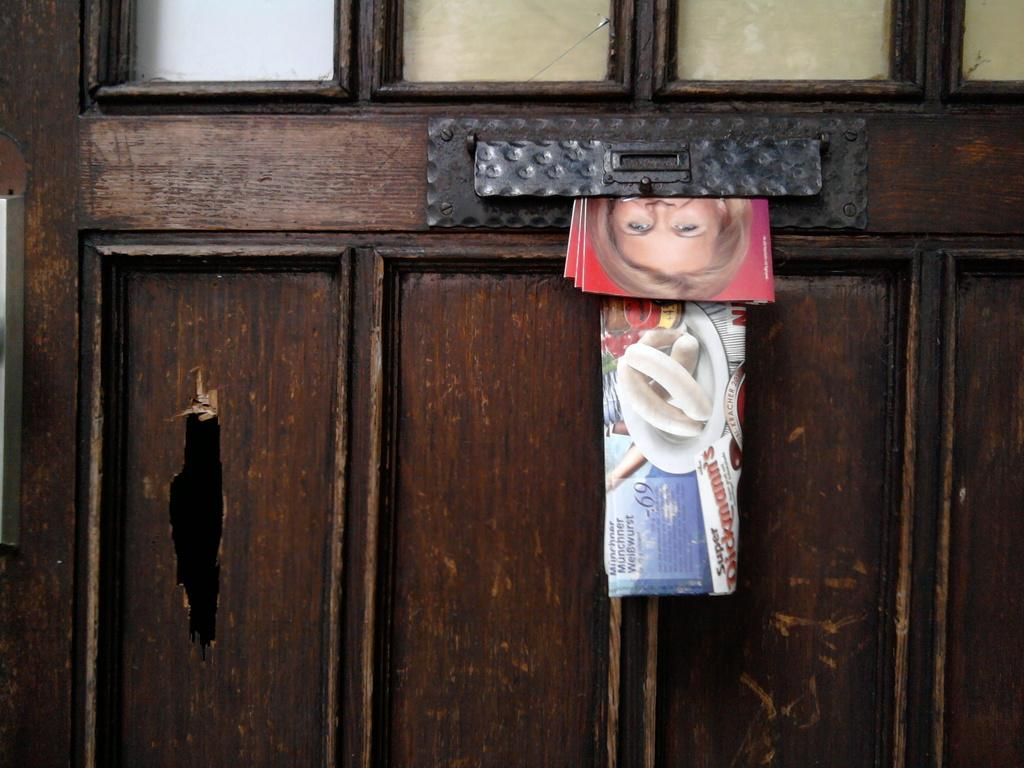What type of material is the object is in the image? There is a wooden object in the image. What is placed on the wooden object? Newspaper and photo books are on the wooden object. How does the beggar use the horn to control the situation in the image? There is no beggar or horn present in the image. 